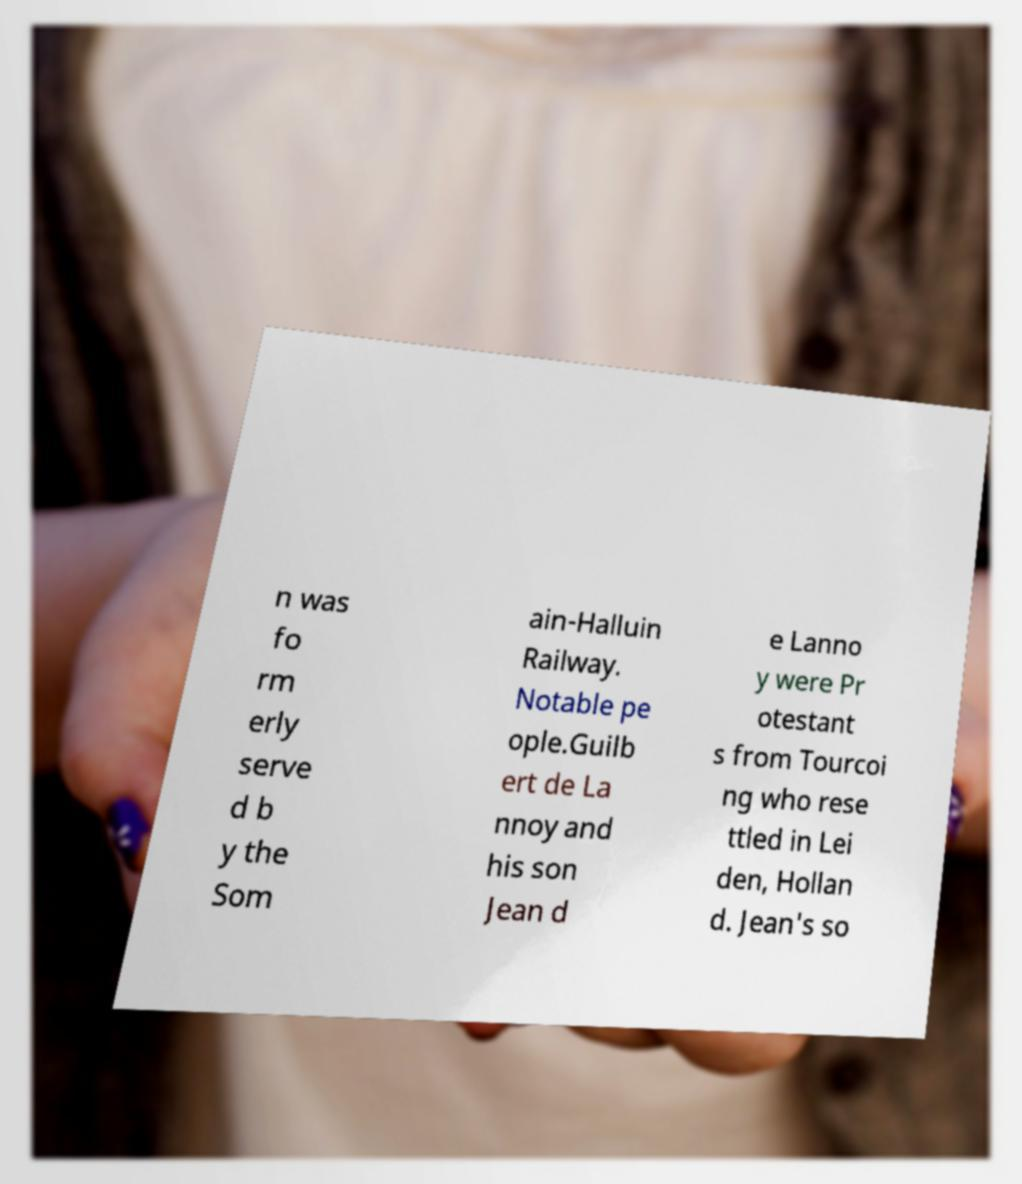There's text embedded in this image that I need extracted. Can you transcribe it verbatim? n was fo rm erly serve d b y the Som ain-Halluin Railway. Notable pe ople.Guilb ert de La nnoy and his son Jean d e Lanno y were Pr otestant s from Tourcoi ng who rese ttled in Lei den, Hollan d. Jean's so 